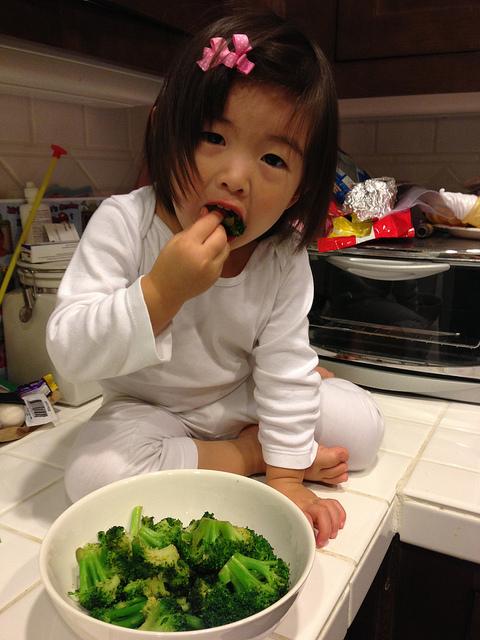Which hand is she eating with?
Concise answer only. Right. What is the girl eating?
Write a very short answer. Broccoli. Where is this girl sitting?
Keep it brief. Counter. What color is her hair?
Write a very short answer. Black. 